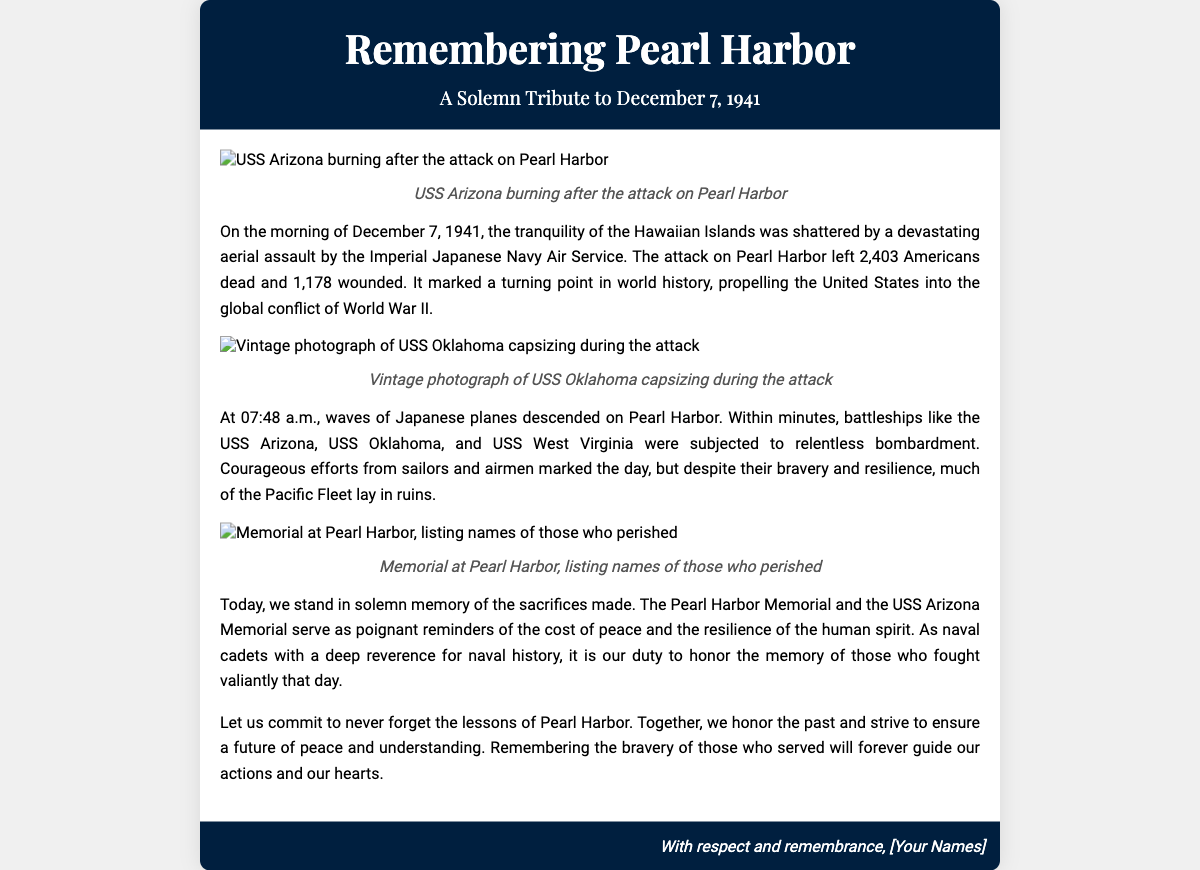what date is remembered in the card? The card recounts events related to December 7, 1941, which is the date of the Pearl Harbor attack.
Answer: December 7, 1941 how many Americans died during the attack? The document states that 2,403 Americans were killed during the attack on Pearl Harbor.
Answer: 2,403 what significant event occurred at 07:48 a.m.? The text notes that at 07:48 a.m., waves of Japanese planes began their attack on Pearl Harbor.
Answer: Attack began which ship is highlighted as burning after the attack? The card features an image captioned "USS Arizona burning after the attack on Pearl Harbor," making it the highlighted ship.
Answer: USS Arizona what does the Pearl Harbor Memorial serve as a reminder of? The document mentions that the Pearl Harbor Memorial serves as a poignant reminder of the cost of peace and the resilience of the human spirit.
Answer: Cost of peace why is it important to remember Pearl Harbor, according to the document? The document emphasizes that remembering Pearl Harbor helps honor the bravery of those who served and ensures a future of peace and understanding.
Answer: Future of peace who helped in the defense during the attack? The text refers to courageous efforts from sailors and airmen marking the day of the attack.
Answer: Sailors and airmen what type of document is this? The document is a greeting card dedicated to honoring the memory of Pearl Harbor.
Answer: Greeting card 